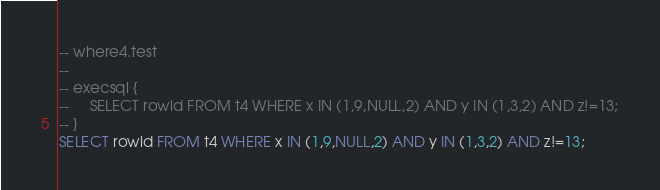<code> <loc_0><loc_0><loc_500><loc_500><_SQL_>-- where4.test
-- 
-- execsql {
--     SELECT rowid FROM t4 WHERE x IN (1,9,NULL,2) AND y IN (1,3,2) AND z!=13;
-- }
SELECT rowid FROM t4 WHERE x IN (1,9,NULL,2) AND y IN (1,3,2) AND z!=13;</code> 